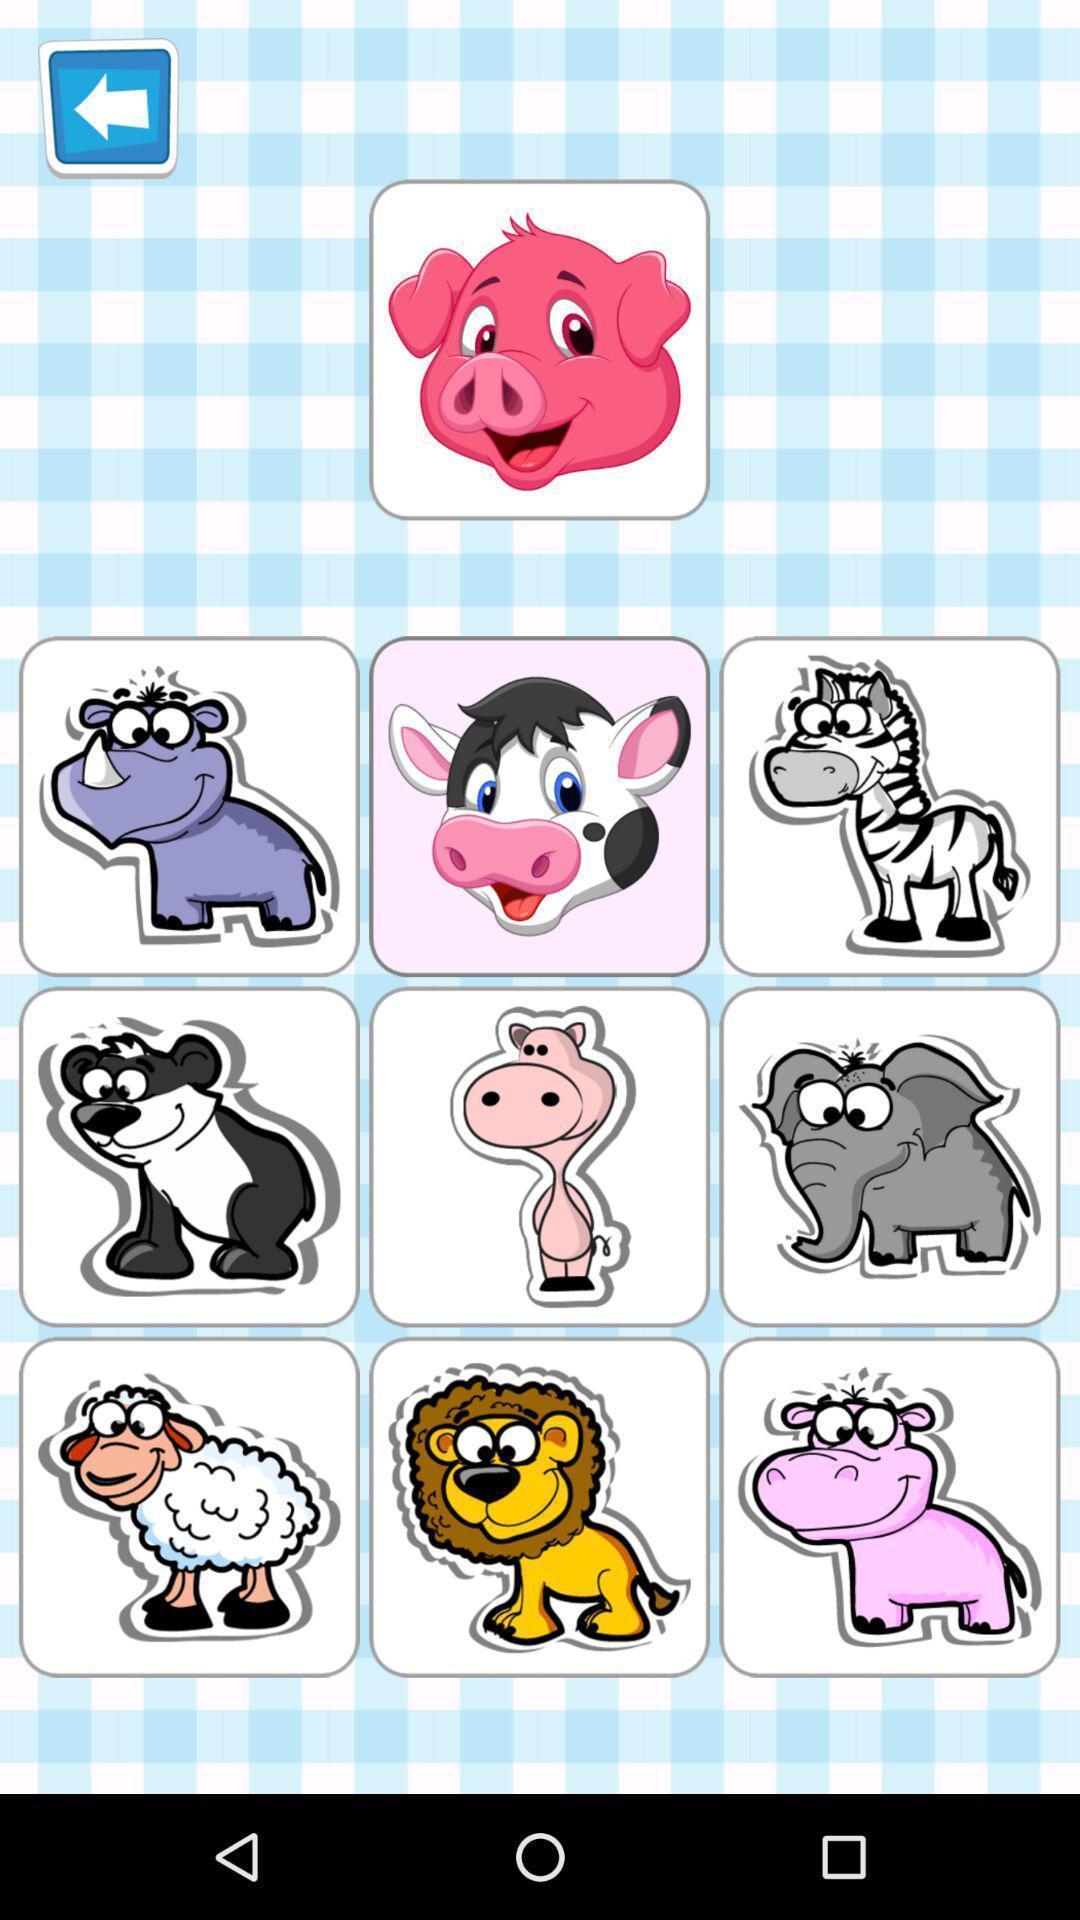Describe the visual elements of this screenshot. Page showing pictures of different animals. 